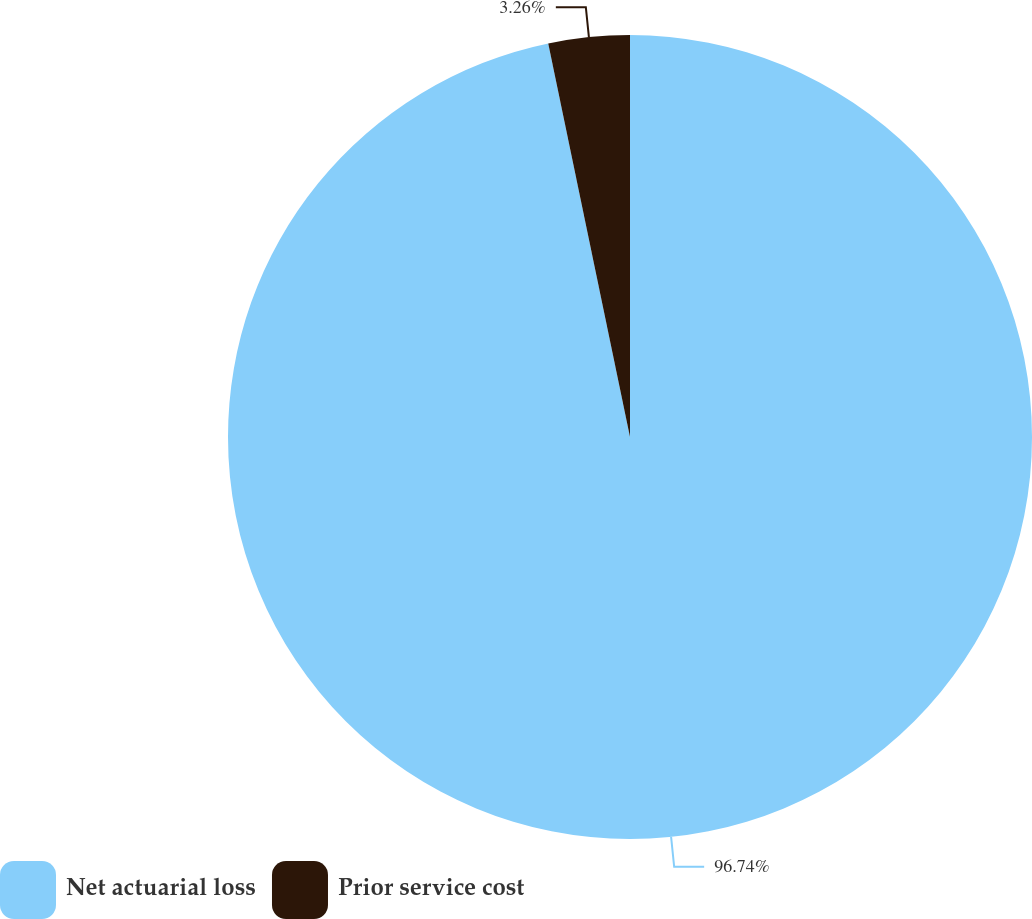<chart> <loc_0><loc_0><loc_500><loc_500><pie_chart><fcel>Net actuarial loss<fcel>Prior service cost<nl><fcel>96.74%<fcel>3.26%<nl></chart> 